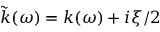<formula> <loc_0><loc_0><loc_500><loc_500>\tilde { k } ( \omega ) = k ( \omega ) + i \xi / 2</formula> 